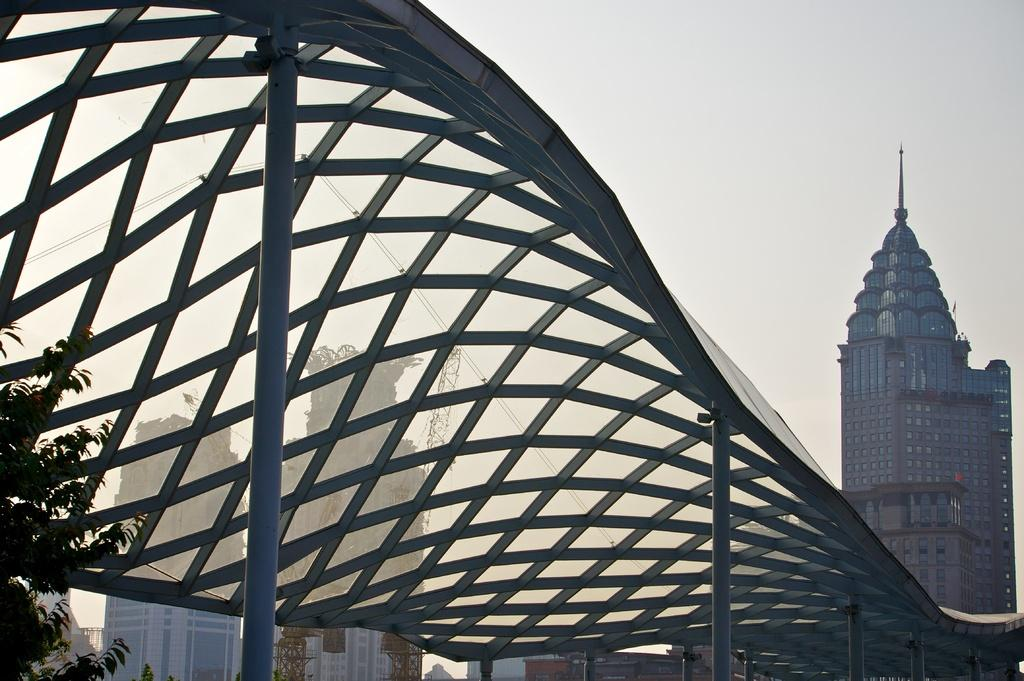What type of roof is visible in the image? There is a glass roof in the image. What can be seen in the background of the image? There are buildings and trees in the background of the image. What color are the buildings in the image? The buildings are white in color. What color are the trees in the image? The trees are green in color. What is the color of the sky in the image? The sky is white in color. How many chairs are placed in the bedroom in the image? There is no bedroom or chairs present in the image. 